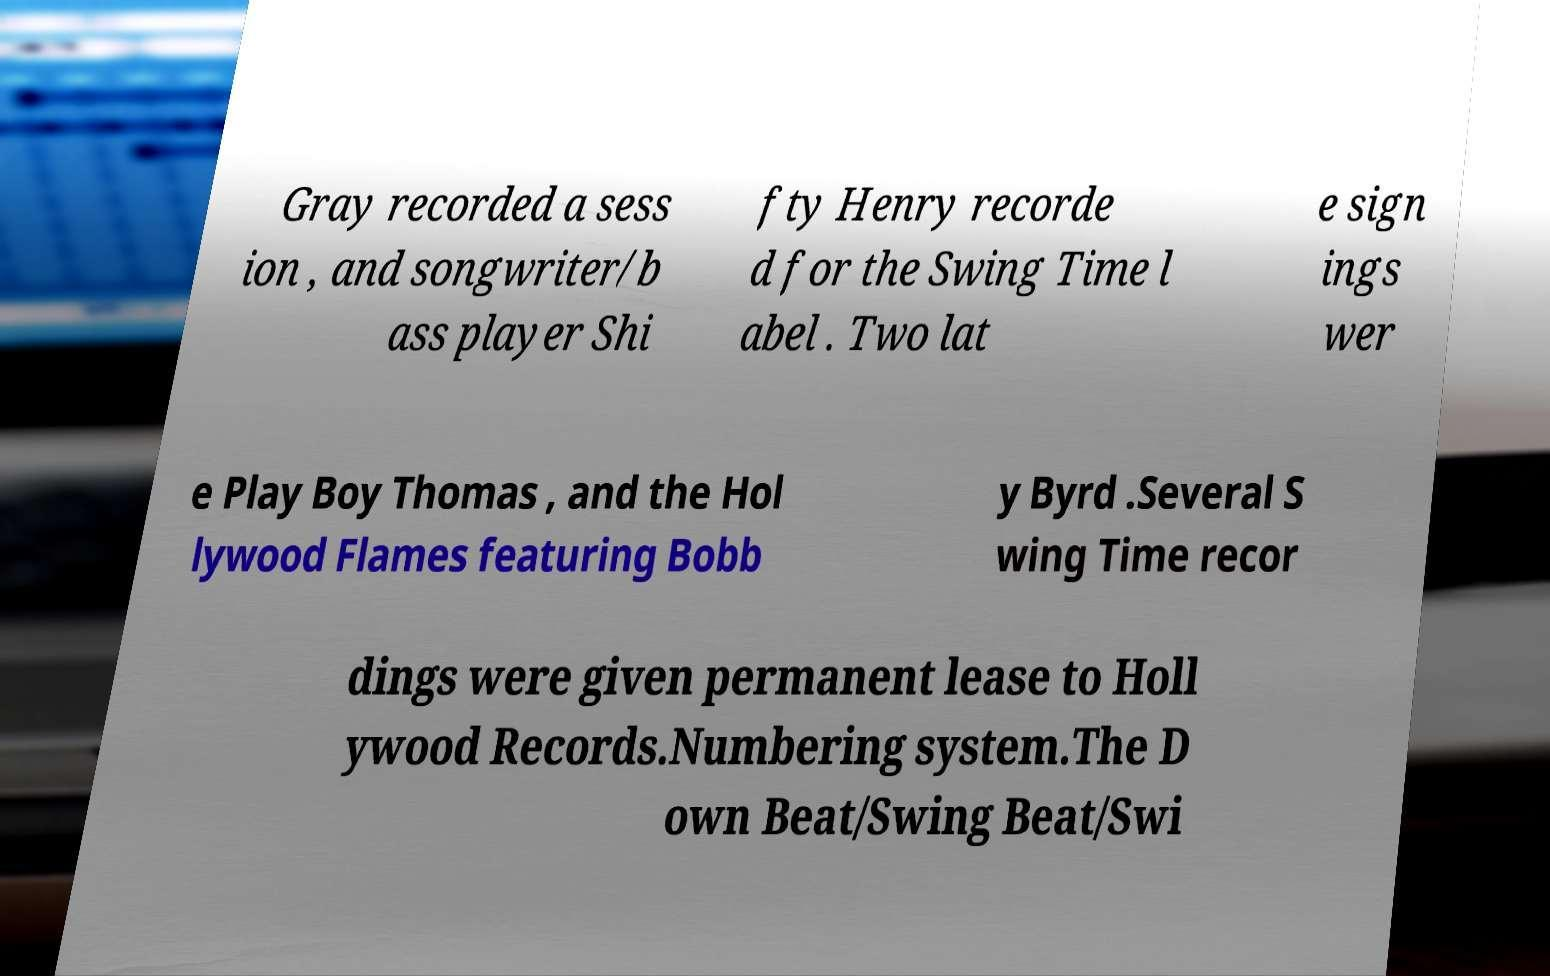What messages or text are displayed in this image? I need them in a readable, typed format. Gray recorded a sess ion , and songwriter/b ass player Shi fty Henry recorde d for the Swing Time l abel . Two lat e sign ings wer e Play Boy Thomas , and the Hol lywood Flames featuring Bobb y Byrd .Several S wing Time recor dings were given permanent lease to Holl ywood Records.Numbering system.The D own Beat/Swing Beat/Swi 